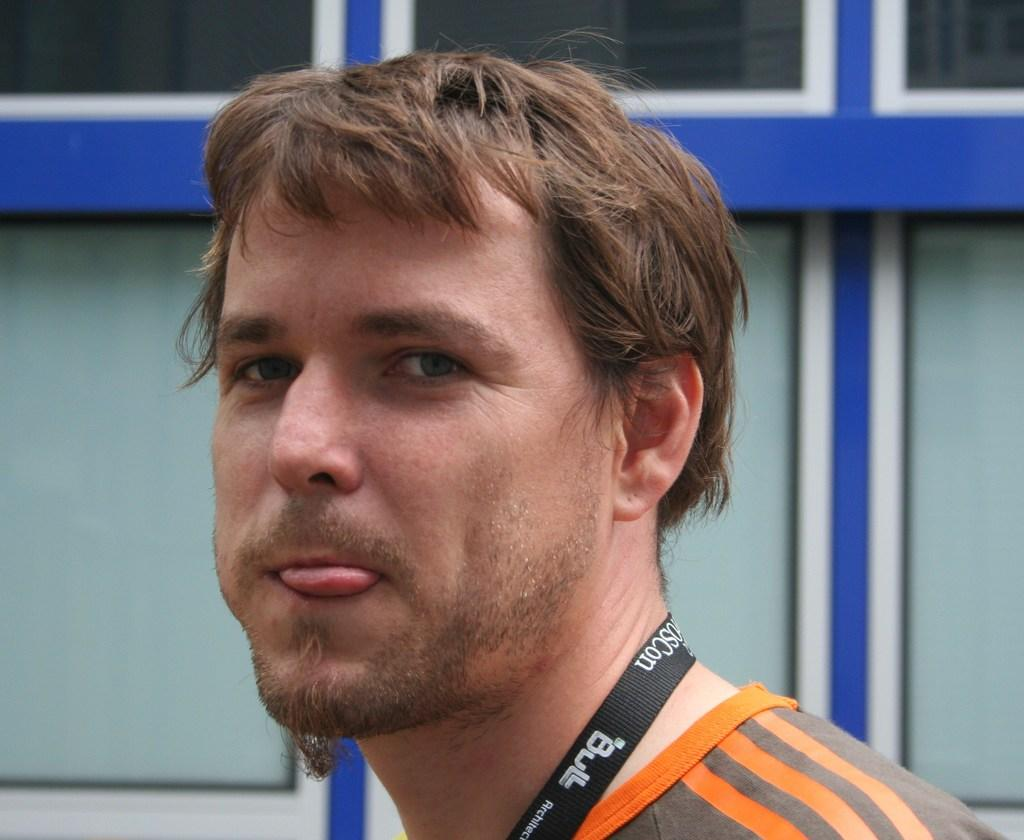Who is present in the image? There is a man in the image. What is the man wearing in the image? The man is wearing a tag in the image. What can be seen in the background of the image? There is a wall and glass in the background of the image. What type of crown is the man wearing in the image? There is no crown present in the image; the man is wearing a tag. What flavor of juice can be seen in the image? There is no juice present in the image. 